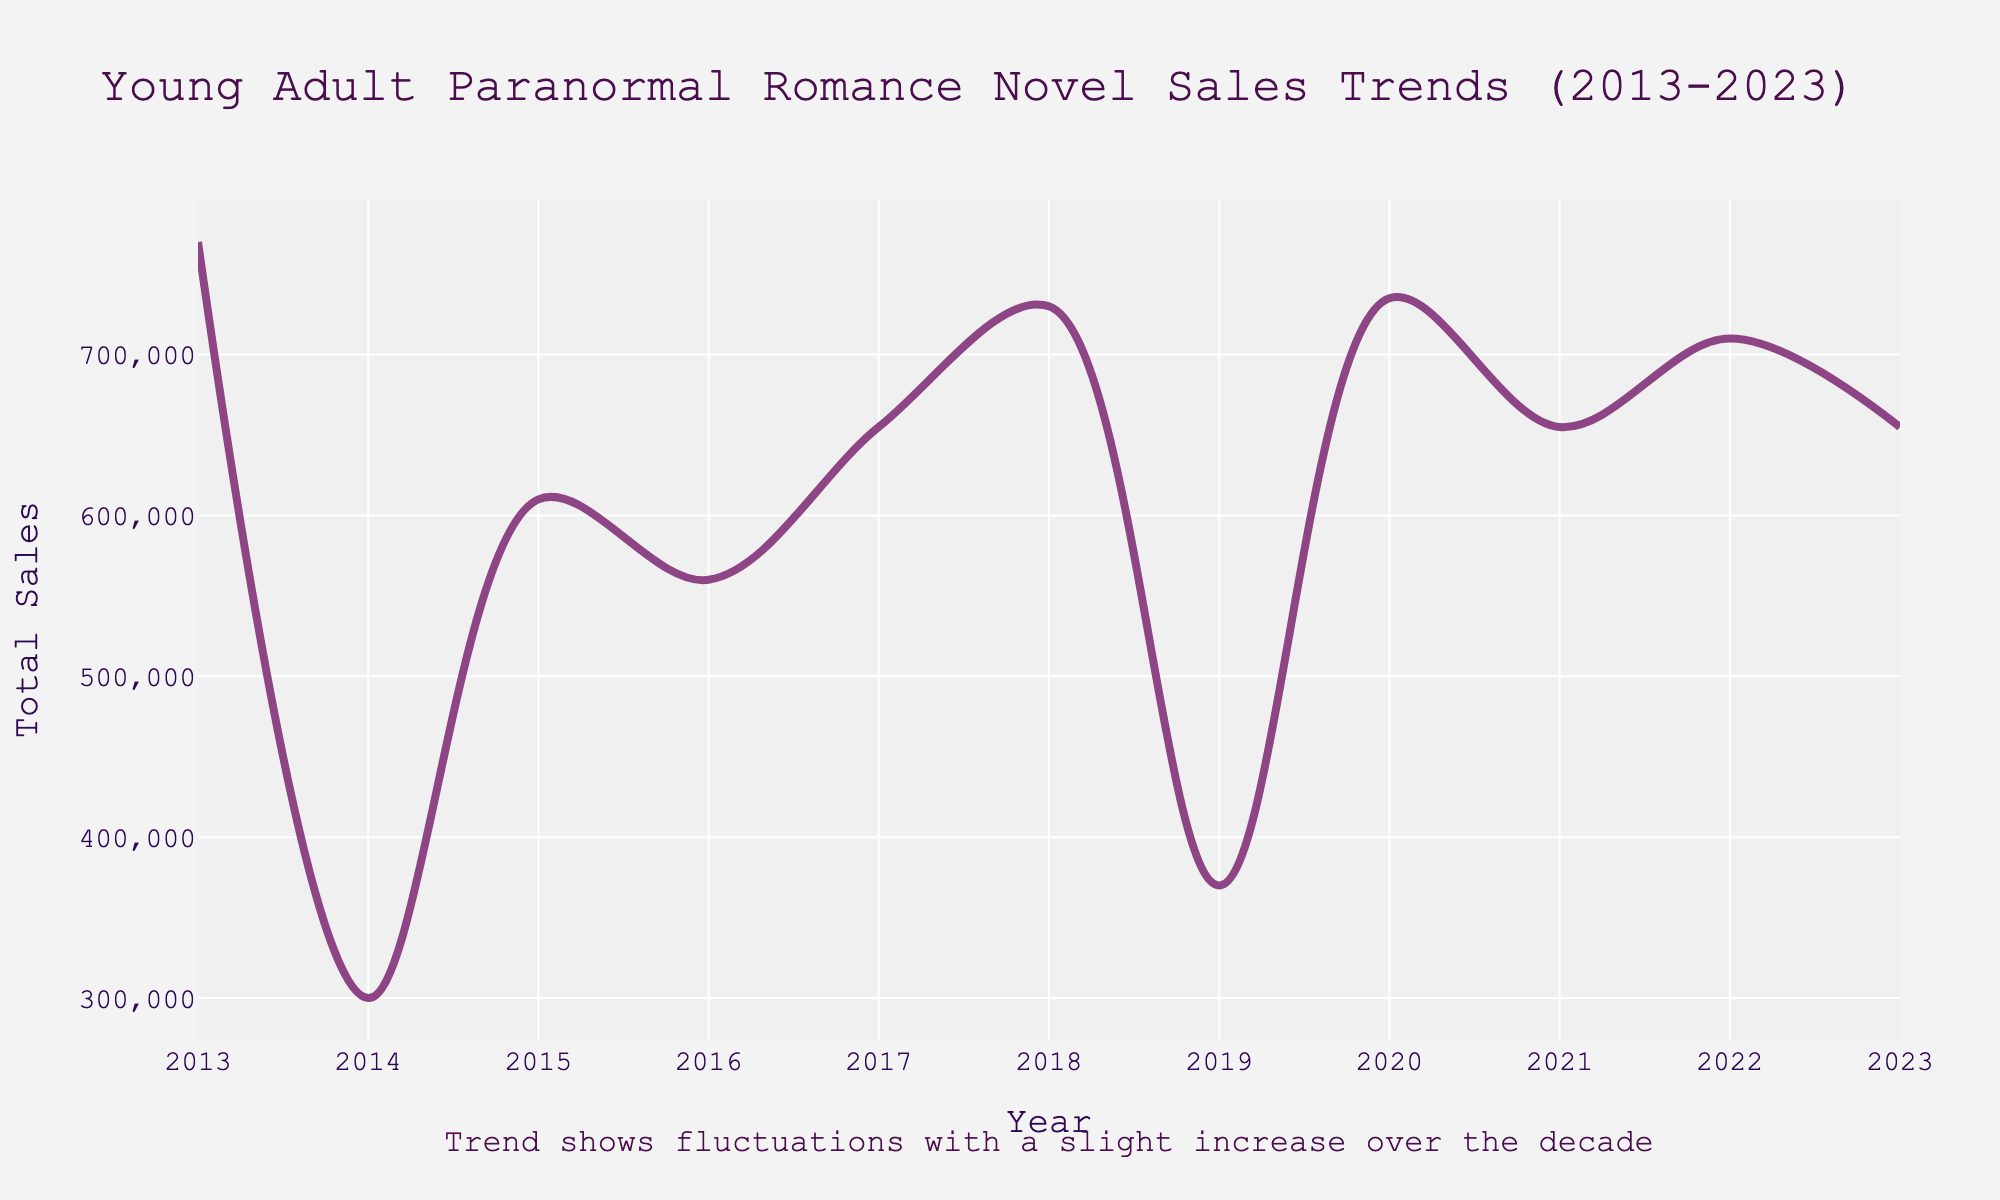what is the title of the plot? The title of the plot is usually found at the top and gives an overview of the data being displayed. Here, it is "Young Adult Paranormal Romance Novel Sales Trends (2013-2023)".
Answer: Young Adult Paranormal Romance Novel Sales Trends (2013-2023) What is the total sales in the year 2020? The total sales for any given year are represented on the y-axis. By locating the year 2020 on the x-axis and tracing it up to the line plot, you can read the y-value, which is approximately 735,000.
Answer: 735,000 How many years are covered in the plot? The plot spans from the year 2013 to the year 2023. Counting the number of distinct years within this range, we find that it covers 11 years of data.
Answer: 11 years Which year had the highest total sales? To find the year with the highest sales, visually inspect the plot to see where the peak occurs. The highest point corresponds to the year 2022.
Answer: 2022 Which year had lower total sales, 2016 or 2017? By comparing the y-values of the points for 2016 and 2017 on the plot, we can determine that 2016 has lower total sales than 2017.
Answer: 2016 Is the sales trend increasing or decreasing over the decade? Observing the general direction of the line plot from 2013 to 2023, it shows fluctuations but indicates a slight overall increase over the decade.
Answer: Slightly increasing What is the average annual sales over the decade? Calculate the sum of total sales for each year, then divide by the number of years (11). The sales are approximately [770,000 + 720,000 + 600,000 + 610,000 + 545,000 + 560,000 + 655,000 + 695,000 + 775,000 + 790,000 + 655,000 = 7,375,000]. The average is 7,375,000 / 11 ≈ 670,000.
Answer: 670,000 Which year experienced the largest increase in sales compared to the previous year? Examining the plot, the largest upward jump in sales occurs between the years 2017 and 2018, indicating this is the period of the most significant increase.
Answer: 2018 When did Sarah J. Maas's books contribute significantly to the peak in sales? Analyzing the time points and noting the sales data detail, Sarah J. Maas's books had a major impact on the high sales years like 2018 and 2022.
Answer: 2018 and 2022 